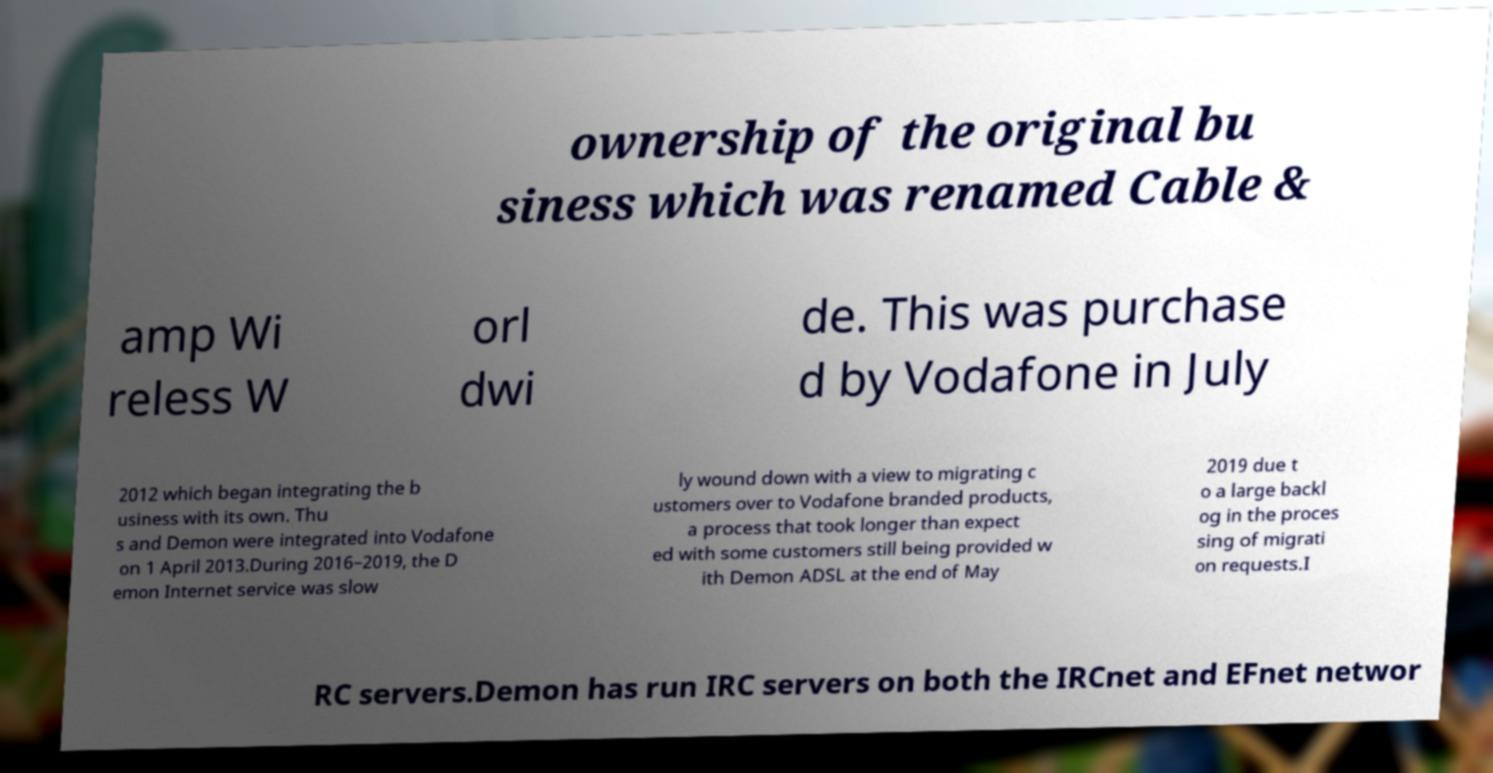Can you read and provide the text displayed in the image?This photo seems to have some interesting text. Can you extract and type it out for me? ownership of the original bu siness which was renamed Cable & amp Wi reless W orl dwi de. This was purchase d by Vodafone in July 2012 which began integrating the b usiness with its own. Thu s and Demon were integrated into Vodafone on 1 April 2013.During 2016–2019, the D emon Internet service was slow ly wound down with a view to migrating c ustomers over to Vodafone branded products, a process that took longer than expect ed with some customers still being provided w ith Demon ADSL at the end of May 2019 due t o a large backl og in the proces sing of migrati on requests.I RC servers.Demon has run IRC servers on both the IRCnet and EFnet networ 